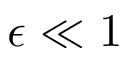<formula> <loc_0><loc_0><loc_500><loc_500>\epsilon \ll 1</formula> 